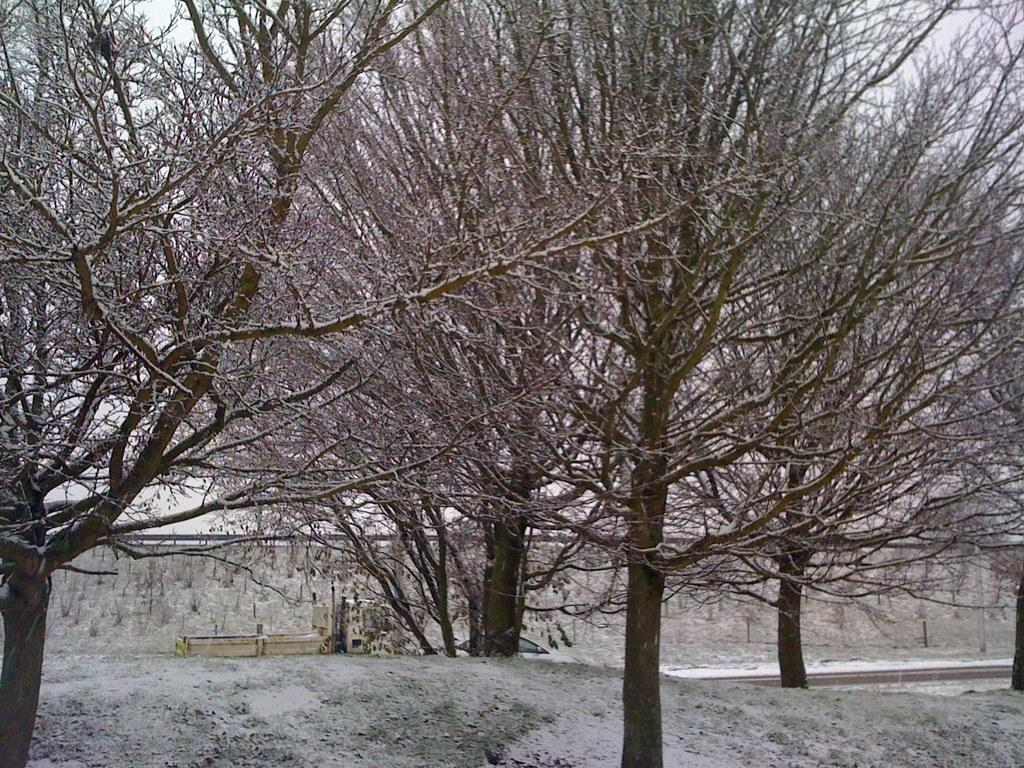What type of trees are visible in the image? There are bare trees in the image. What can be inferred about the season from the appearance of the trees? The bare trees suggest that it is likely winter or a time when leaves have fallen from the trees. Are there any other objects or features visible in the image? The provided facts do not mention any other objects or features in the image. What type of underwear is hanging on the tree in the image? There is no underwear present in the image; it only features bare trees. How many bulbs are visible on the tree in the image? There are no bulbs present in the image; it only features bare trees. 